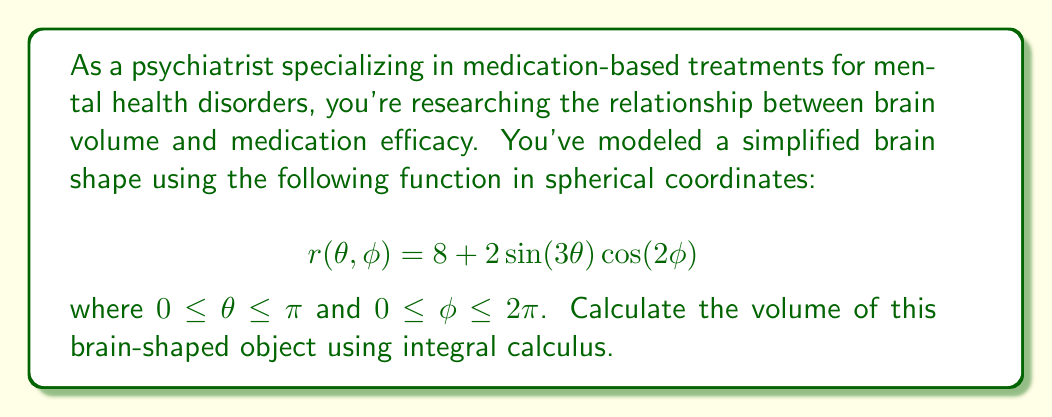Can you solve this math problem? To calculate the volume of this brain-shaped object, we'll use the triple integral formula for volume in spherical coordinates:

$$V = \int_0^{2\pi} \int_0^{\pi} \int_0^{r(\theta,\phi)} \rho^2 \sin(\theta) \, d\rho \, d\theta \, d\phi$$

Step 1: Set up the integral with the given function:
$$V = \int_0^{2\pi} \int_0^{\pi} \int_0^{8 + 2\sin(3\theta)\cos(2\phi)} \rho^2 \sin(\theta) \, d\rho \, d\theta \, d\phi$$

Step 2: Evaluate the innermost integral with respect to $\rho$:
$$V = \int_0^{2\pi} \int_0^{\pi} \frac{1}{3}(8 + 2\sin(3\theta)\cos(2\phi))^3 \sin(\theta) \, d\theta \, d\phi$$

Step 3: Expand the cube:
$$V = \int_0^{2\pi} \int_0^{\pi} \frac{1}{3}(512 + 384\sin(3\theta)\cos(2\phi) + 96\sin^2(3\theta)\cos^2(2\phi) + 8\sin^3(3\theta)\cos^3(2\phi)) \sin(\theta) \, d\theta \, d\phi$$

Step 4: Integrate with respect to $\theta$:
$$V = \int_0^{2\pi} [\frac{512}{3}(-\cos(\theta)) + 384\cdot\frac{1}{3}\cos(2\phi)\cdot\frac{1}{3}(\cos(3\theta)-1) + \text{terms that integrate to zero}]_0^{\pi} \, d\phi$$

Step 5: Evaluate the $\theta$ integral:
$$V = \int_0^{2\pi} (340.6667 - 256\cos(2\phi)) \, d\phi$$

Step 6: Integrate with respect to $\phi$:
$$V = [340.6667\phi - 128\sin(2\phi)]_0^{2\pi}$$

Step 7: Evaluate the final integral:
$$V = 340.6667 \cdot 2\pi - 0 = 2138.2$$

Therefore, the volume of the brain-shaped object is approximately 2138.2 cubic units.
Answer: $2138.2$ cubic units 